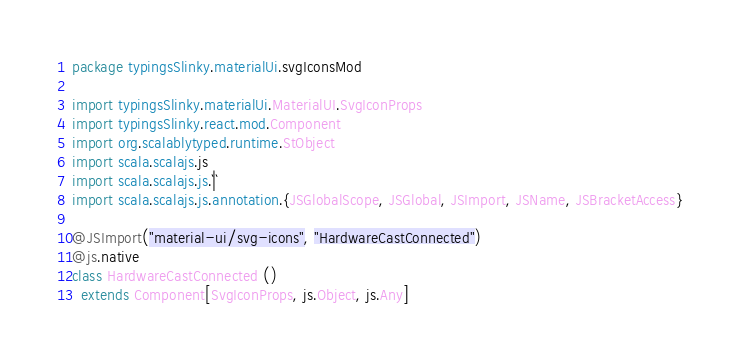Convert code to text. <code><loc_0><loc_0><loc_500><loc_500><_Scala_>package typingsSlinky.materialUi.svgIconsMod

import typingsSlinky.materialUi.MaterialUI.SvgIconProps
import typingsSlinky.react.mod.Component
import org.scalablytyped.runtime.StObject
import scala.scalajs.js
import scala.scalajs.js.`|`
import scala.scalajs.js.annotation.{JSGlobalScope, JSGlobal, JSImport, JSName, JSBracketAccess}

@JSImport("material-ui/svg-icons", "HardwareCastConnected")
@js.native
class HardwareCastConnected ()
  extends Component[SvgIconProps, js.Object, js.Any]
</code> 